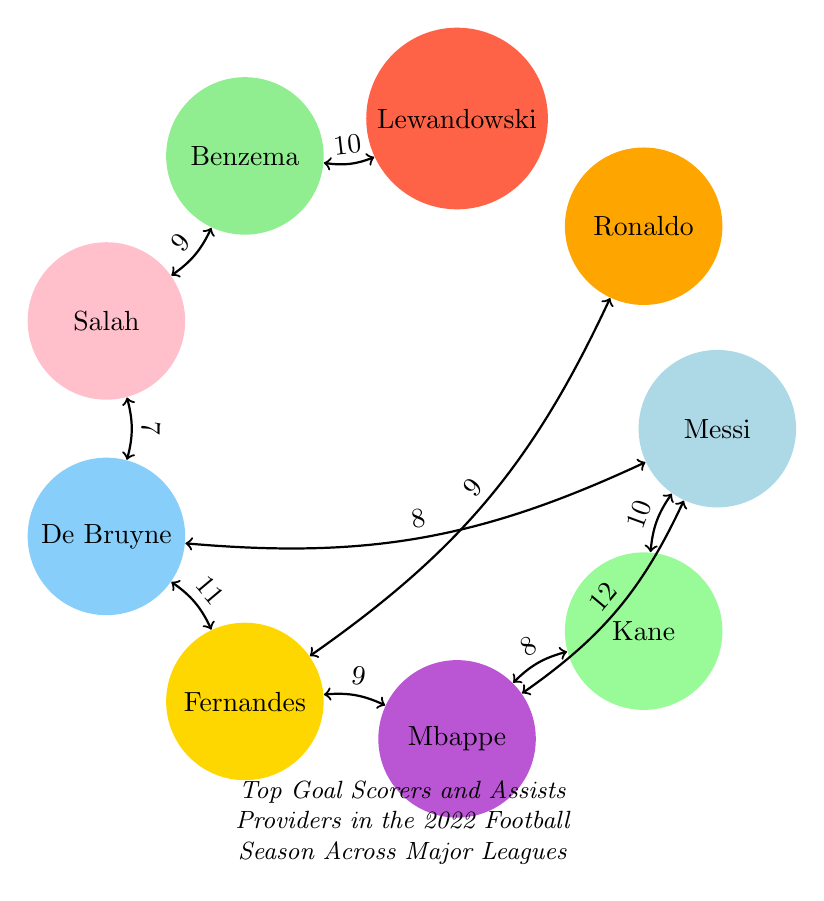What's the total number of nodes in the diagram? The diagram contains nine nodes representing different football players: Lionel Messi, Cristiano Ronaldo, Robert Lewandowski, Karim Benzema, Mohamed Salah, Kevin De Bruyne, Bruno Fernandes, Kylian Mbappe, and Harry Kane. Counting these gives a total of nine nodes.
Answer: 9 What is the highest number of assists recorded in the diagram? The largest number shown in the links for assists is 12, which is from Lionel Messi to Kylian Mbappe. Therefore, the highest number of assists recorded is 12.
Answer: 12 Who provided the most assists to Kevin De Bruyne? The only connection directed towards Kevin De Bruyne from Messi indicates Messi provided 8 assists to him. Since it's the only link attached to Kevin De Bruyne, he is the one who has the most assists provided by Messi.
Answer: Lionel Messi Which player assisted Harry Kane the most? The diagram shows a link from Kylian Mbappe to Harry Kane with a value of 8 assists. Since it is the only link to Kane, this is the assist he received.
Answer: Kylian Mbappe How many total assists did Bruno Fernandes provide according to the diagram? Bruno Fernandes has three connections: one to Cristiano Ronaldo with 9 assists, another to Marcus Rashford with 9 assists, and one more to Kylian Mbappe with 9 assists. Summing them gives 9 + 9 = 18 assists.
Answer: 18 Which player received the fewest assists in the diagram? By reviewing the connections, we see that Sadio Mane received 7 assists from Mohamed Salah, which is the least amount of assists any player in the diagram received.
Answer: Sadio Mane Which two players have the most assists between them? The diagram shows the highest value of assists between two players is 12 between Messi and Mbappe. This is the most significant total of assists between any two players in the diagram.
Answer: Messi and Mbappe What is the relationship between Robert Lewandowski and Karim Benzema? The diagram indicates an assist value of 10 from Robert Lewandowski to Karim Benzema, meaning Lewandowski provided 10 assists to Benzema during the season.
Answer: 10 assists Is there a player who has assisted both Mohamed Salah and Kevin De Bruyne? Yes, the link shows that Kevin De Bruyne assisted Salah, and Messi also assisted De Bruyne, meaning Messi has connections with both Salah and De Bruyne, confirming he assisted both.
Answer: Yes, Lionel Messi 